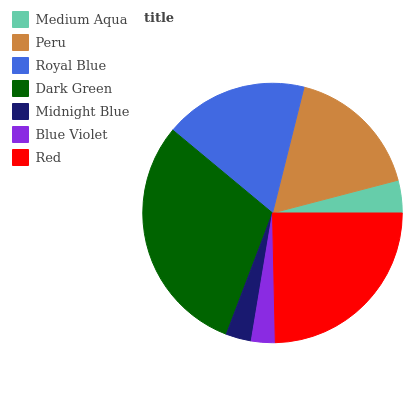Is Blue Violet the minimum?
Answer yes or no. Yes. Is Dark Green the maximum?
Answer yes or no. Yes. Is Peru the minimum?
Answer yes or no. No. Is Peru the maximum?
Answer yes or no. No. Is Peru greater than Medium Aqua?
Answer yes or no. Yes. Is Medium Aqua less than Peru?
Answer yes or no. Yes. Is Medium Aqua greater than Peru?
Answer yes or no. No. Is Peru less than Medium Aqua?
Answer yes or no. No. Is Peru the high median?
Answer yes or no. Yes. Is Peru the low median?
Answer yes or no. Yes. Is Red the high median?
Answer yes or no. No. Is Royal Blue the low median?
Answer yes or no. No. 